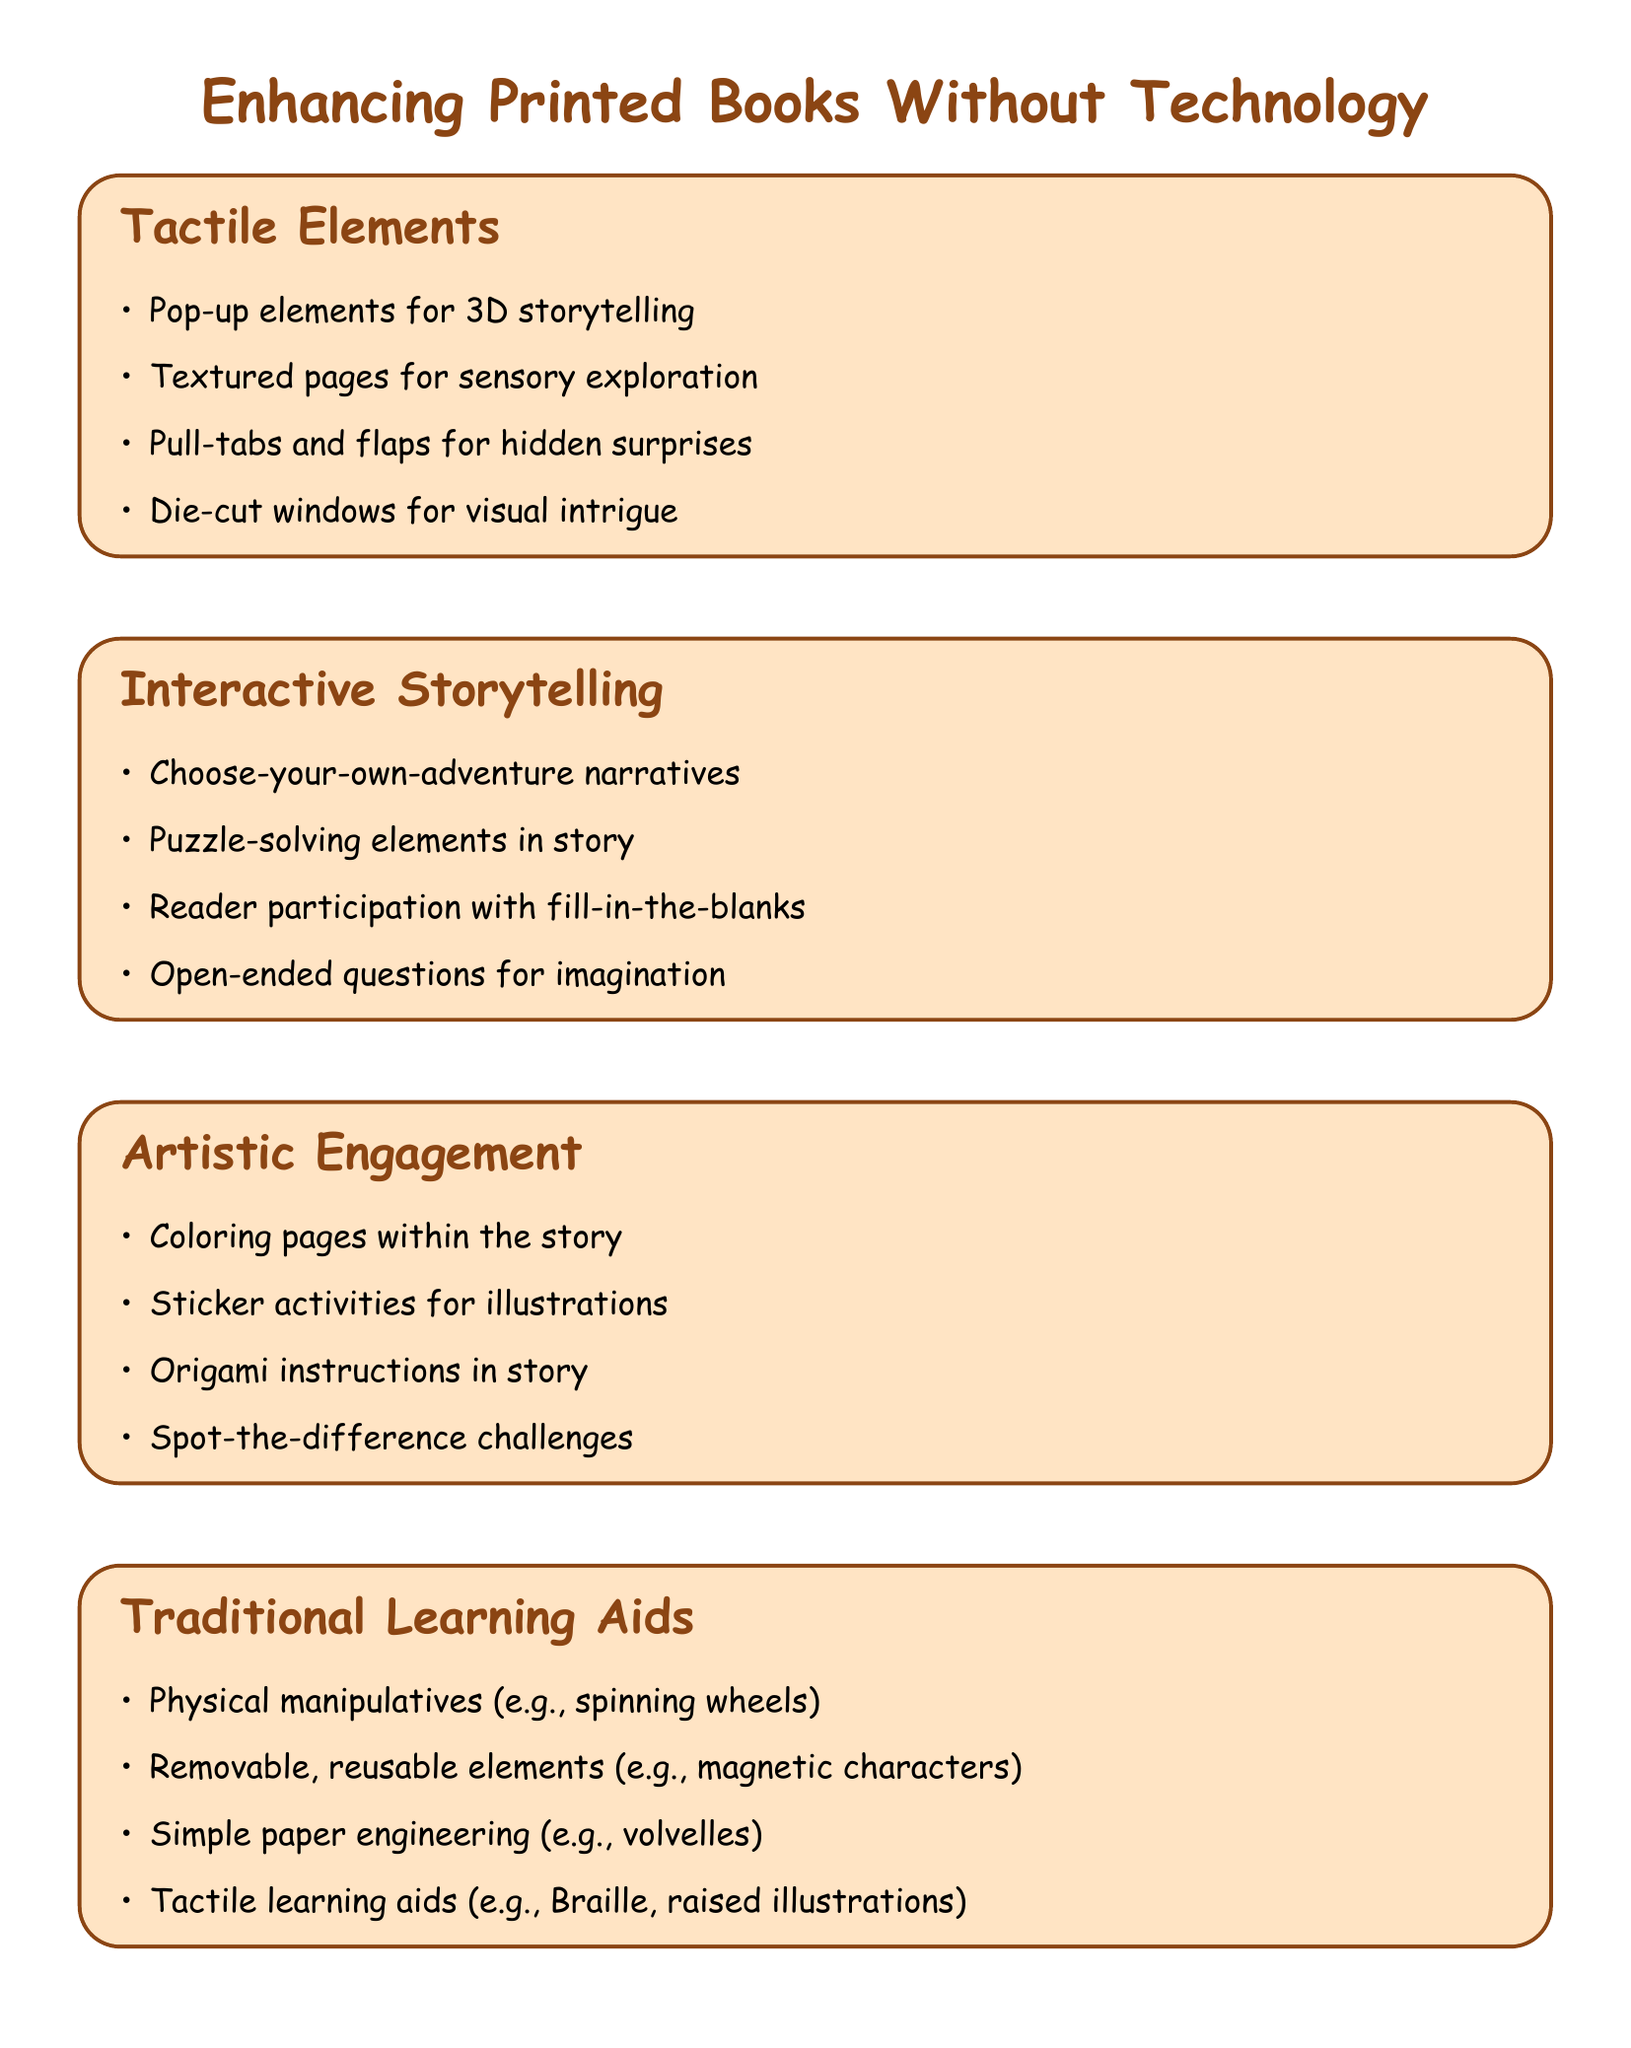What is the first topic listed in the document? The first topic is an element mentioned under tactile elements in printed books.
Answer: Tactile Elements How many artistic engagement methods are suggested? The section on artistic engagement methods lists four techniques.
Answer: Four What is an example of a traditional learning enhancement mentioned? The document lists removable and reusable elements as part of traditional learning enhancements.
Answer: Removable, reusable elements Which method encourages imagination through story engagement? The document mentions that open-ended questions stimulate reader imagination.
Answer: Open-ended questions What type of skills does non-digital interactivity promote? The benefits section highlights that interactivity promotes fine motor skills development.
Answer: Fine motor skills Which activity involves coloring within the story? The artistic engagement methods include coloring pages as a suggested activity.
Answer: Coloring pages What is one benefit of engaging without screens? The document cites fostering creativity as a direct benefit of non-digital interactivity.
Answer: Fosters creativity What are the tactile learning aids mentioned? The document specifies Braille translations and raised illustrations as tactile learning aids.
Answer: Braille translations, raised illustrations 